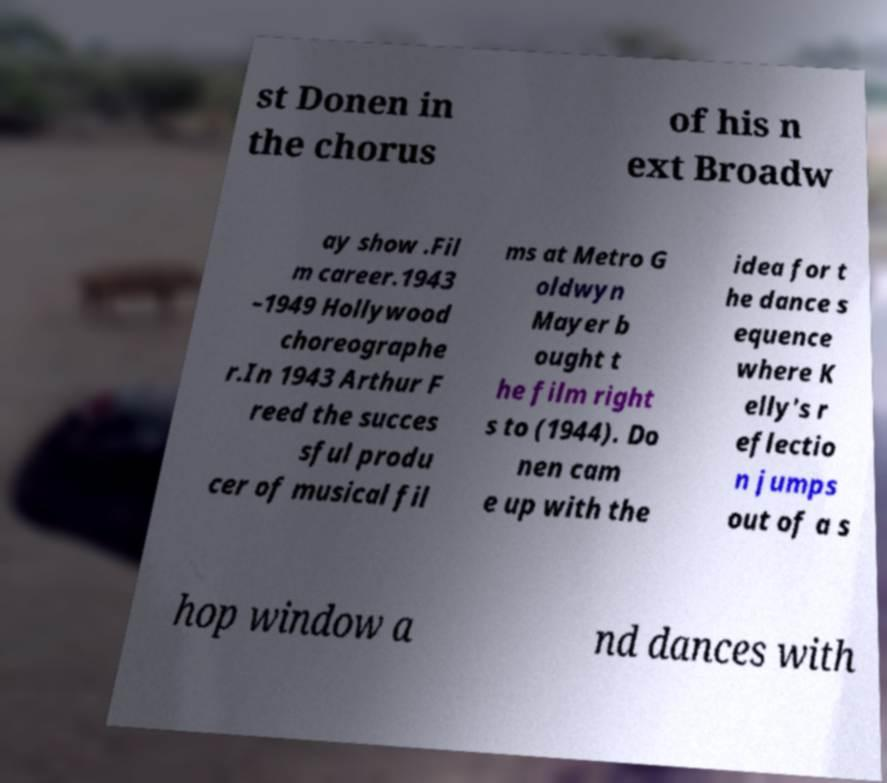I need the written content from this picture converted into text. Can you do that? st Donen in the chorus of his n ext Broadw ay show .Fil m career.1943 –1949 Hollywood choreographe r.In 1943 Arthur F reed the succes sful produ cer of musical fil ms at Metro G oldwyn Mayer b ought t he film right s to (1944). Do nen cam e up with the idea for t he dance s equence where K elly's r eflectio n jumps out of a s hop window a nd dances with 